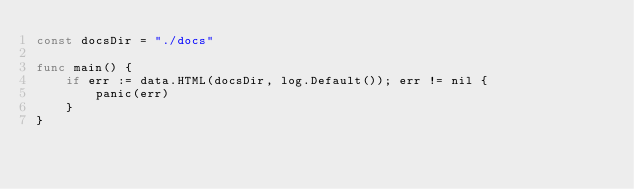<code> <loc_0><loc_0><loc_500><loc_500><_Go_>const docsDir = "./docs"

func main() {
	if err := data.HTML(docsDir, log.Default()); err != nil {
		panic(err)
	}
}
</code> 